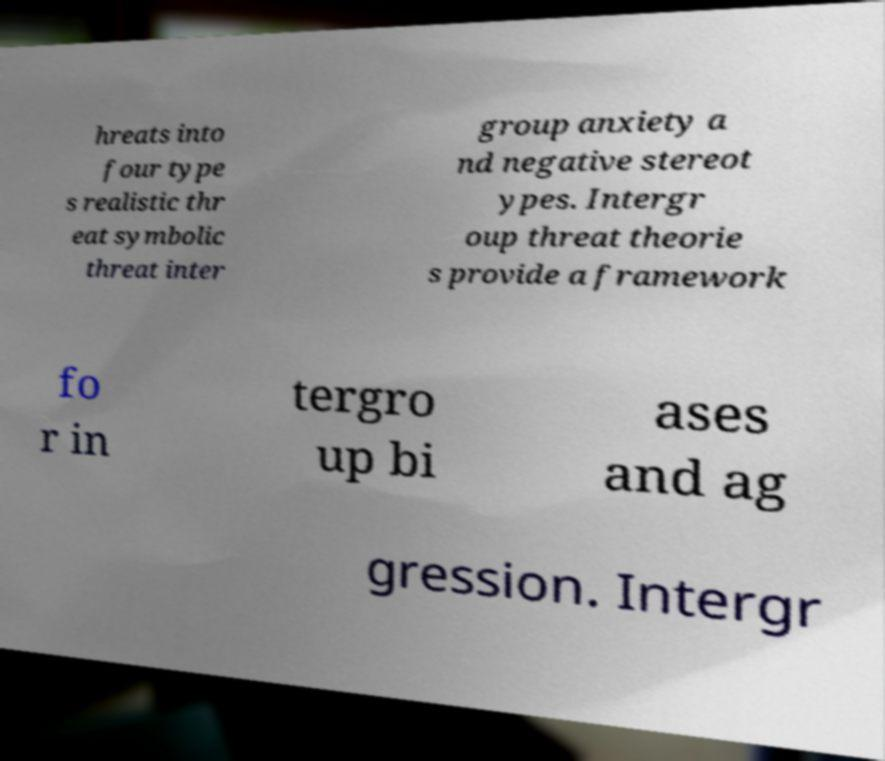Could you extract and type out the text from this image? hreats into four type s realistic thr eat symbolic threat inter group anxiety a nd negative stereot ypes. Intergr oup threat theorie s provide a framework fo r in tergro up bi ases and ag gression. Intergr 